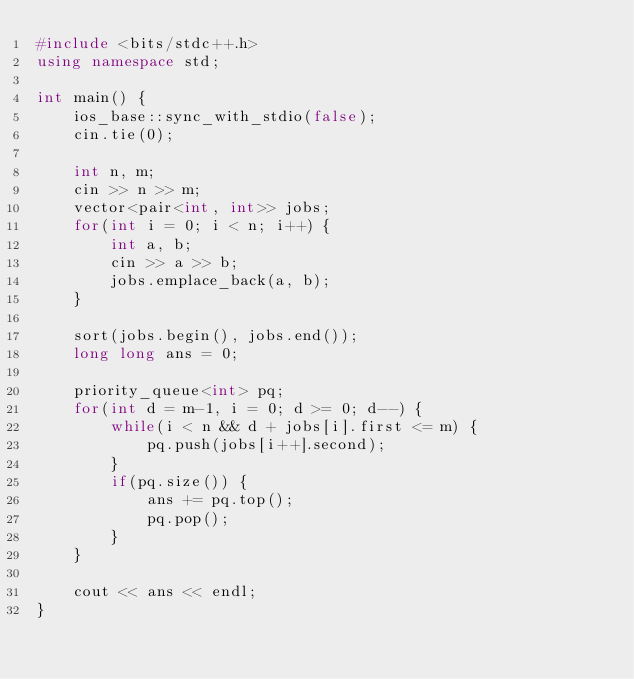<code> <loc_0><loc_0><loc_500><loc_500><_C++_>#include <bits/stdc++.h>
using namespace std;

int main() {
	ios_base::sync_with_stdio(false);
	cin.tie(0);
	
	int n, m;
	cin >> n >> m;
	vector<pair<int, int>> jobs;
	for(int i = 0; i < n; i++) {
		int a, b;
		cin >> a >> b;
		jobs.emplace_back(a, b);
	}
	
	sort(jobs.begin(), jobs.end());
	long long ans = 0;
	
	priority_queue<int> pq;
	for(int d = m-1, i = 0; d >= 0; d--) {
		while(i < n && d + jobs[i].first <= m) {
			pq.push(jobs[i++].second);
		}
		if(pq.size()) {
			ans += pq.top();
			pq.pop();
		}
	}
	
	cout << ans << endl;
}
</code> 